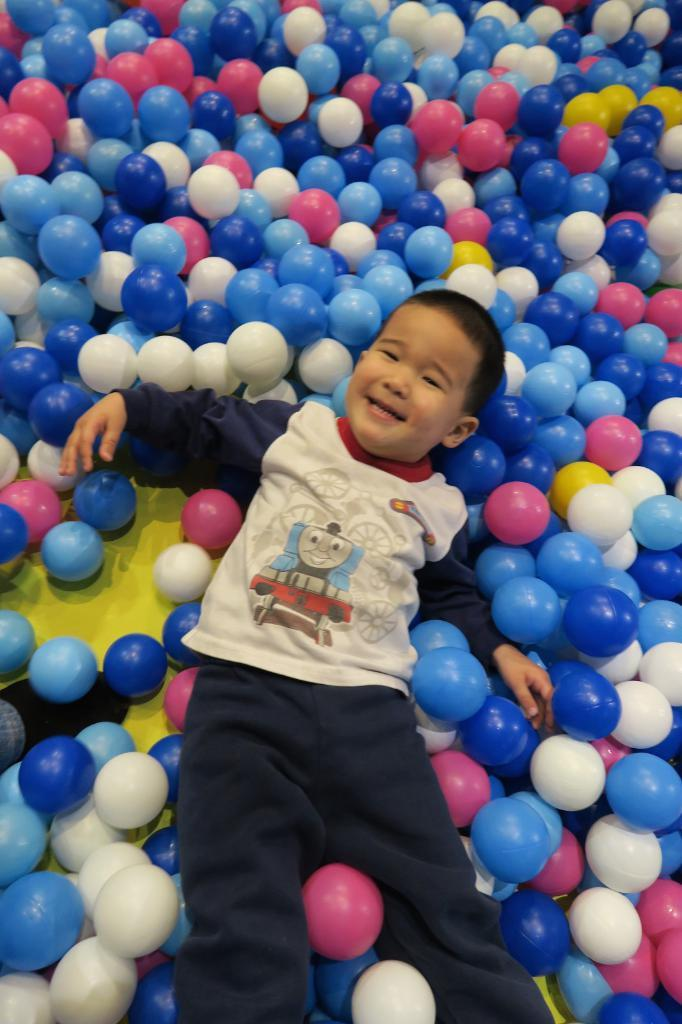Who is the main subject in the image? There is a boy in the image. What is the boy doing in the image? The boy is lying on colored balls. What expression does the boy have in the image? The boy is smiling. What type of range can be seen in the background of the image? There is no range visible in the image; it features a boy lying on colored balls and smiling. How many goldfish are swimming in the hole in the image? There are no goldfish or holes present in the image. 